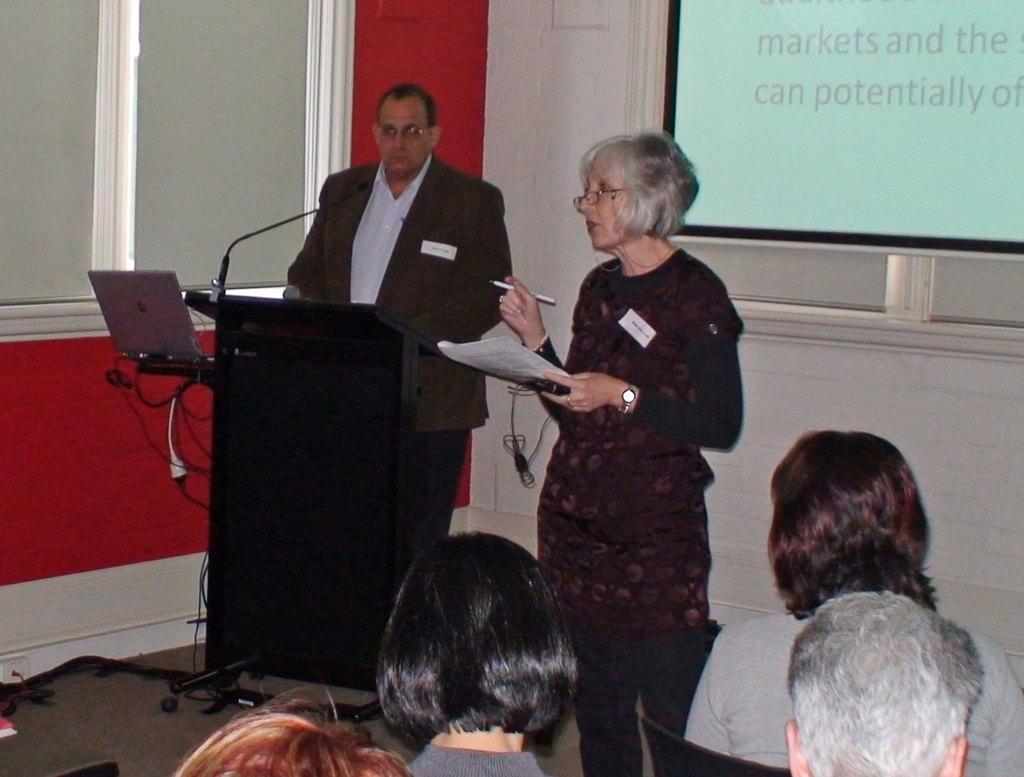Describe this image in one or two sentences. There are people seated in a room. 2 people are standing at the back. There is a microphone, laptop and wires on the tables. There are windows and a projector display at the back. 